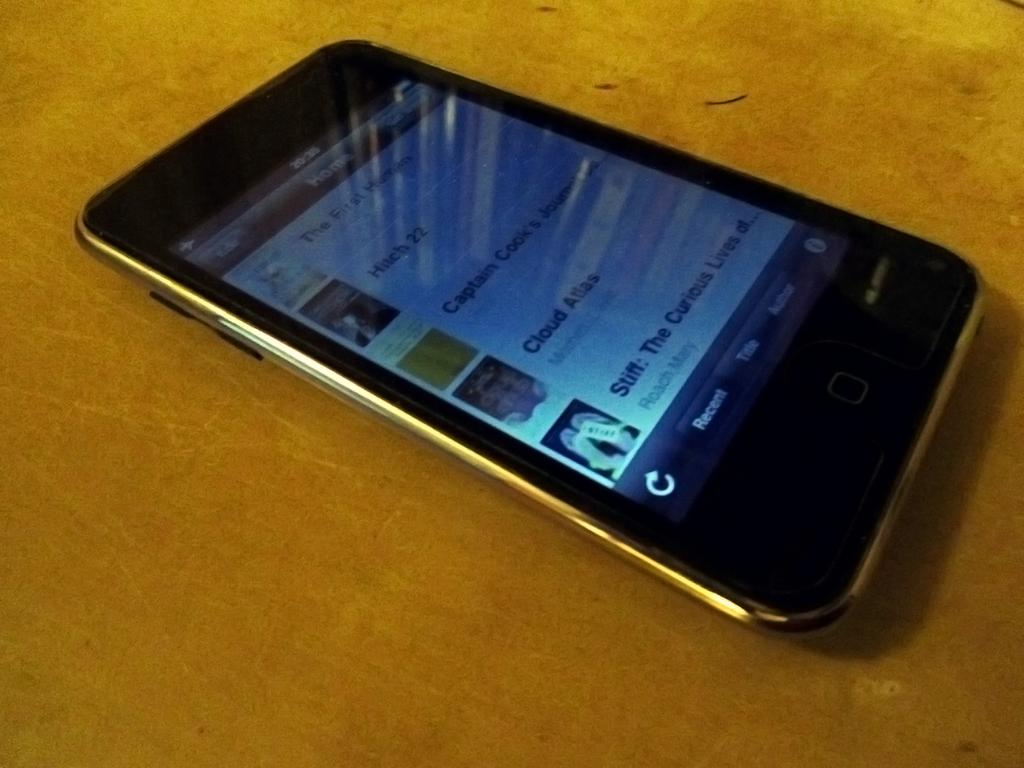<image>
Write a terse but informative summary of the picture. A cell phone displaying some ebooks with Hitch 22 on the top of the list. 